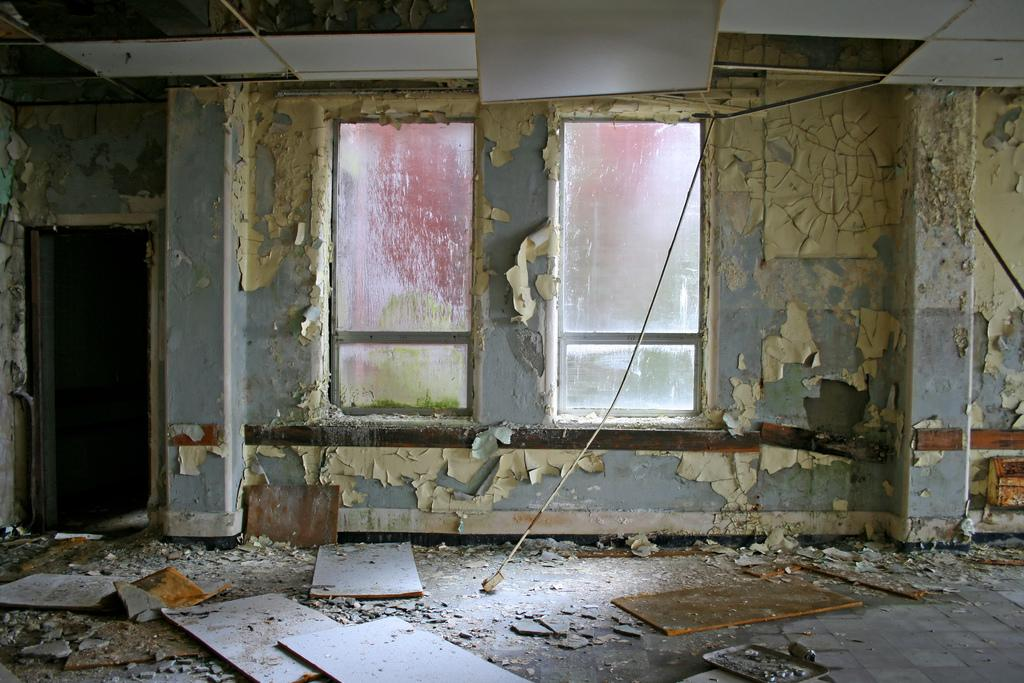What type of location is depicted in the image? The image is taken inside an old building. What can be seen in the center of the image? There is a wall in the center of the image. What architectural features are visible in the image? There are windows and a door in the image. What objects are present at the bottom of the image? Wooden blocks are present at the bottom of the image. What language are the babies speaking in the image? There are no babies present in the image, so it is not possible to determine what language they might be speaking. 